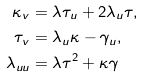<formula> <loc_0><loc_0><loc_500><loc_500>\kappa _ { v } & = \lambda \tau _ { u } + 2 \lambda _ { u } \tau , \\ \tau _ { v } & = \lambda _ { u } \kappa - \gamma _ { u } , \\ \lambda _ { u u } & = \lambda \tau ^ { 2 } + \kappa \gamma</formula> 